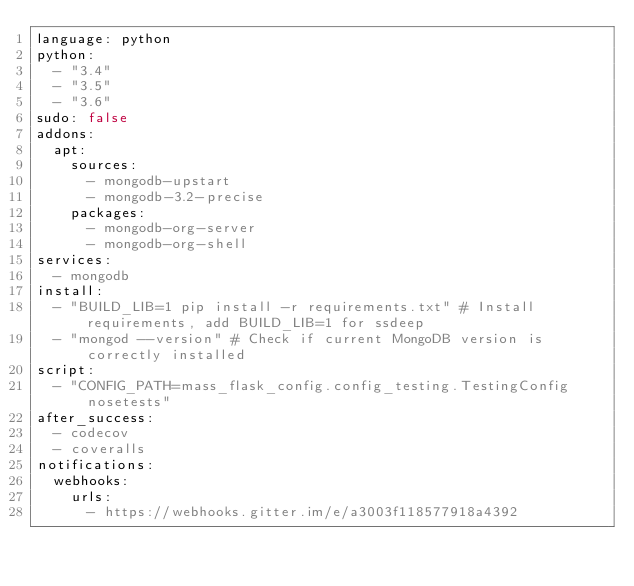Convert code to text. <code><loc_0><loc_0><loc_500><loc_500><_YAML_>language: python
python:
  - "3.4"
  - "3.5"
  - "3.6"
sudo: false
addons:
  apt:
    sources:
      - mongodb-upstart
      - mongodb-3.2-precise
    packages:
      - mongodb-org-server
      - mongodb-org-shell
services:
  - mongodb
install:
  - "BUILD_LIB=1 pip install -r requirements.txt" # Install requirements, add BUILD_LIB=1 for ssdeep
  - "mongod --version" # Check if current MongoDB version is correctly installed
script:
  - "CONFIG_PATH=mass_flask_config.config_testing.TestingConfig nosetests"
after_success:
  - codecov
  - coveralls
notifications:
  webhooks:
    urls:
      - https://webhooks.gitter.im/e/a3003f118577918a4392
</code> 